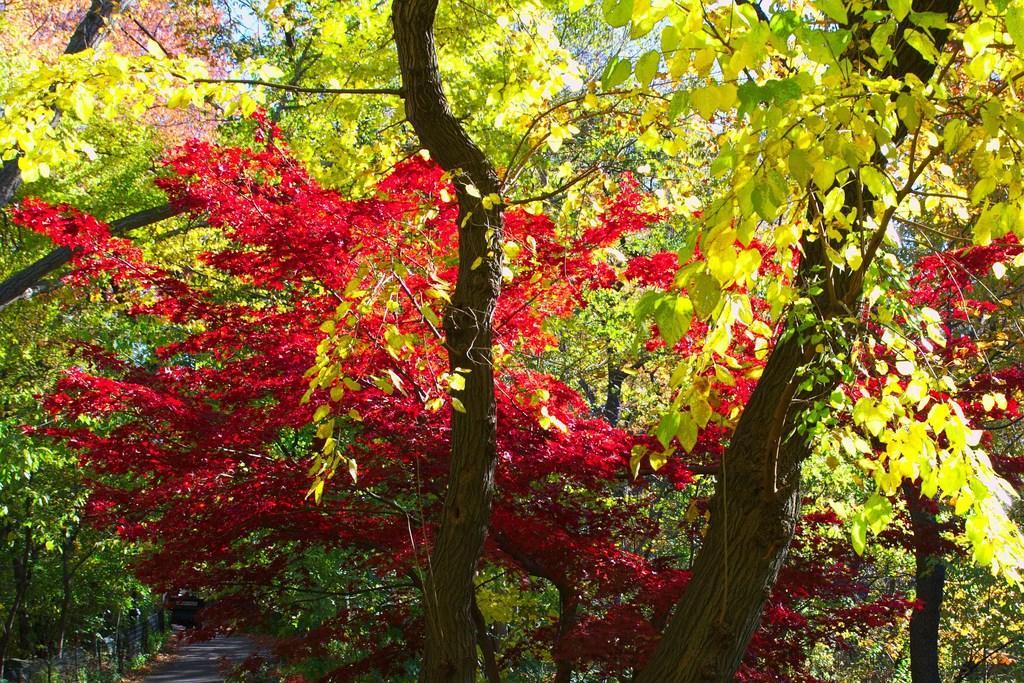Could you give a brief overview of what you see in this image? In this image we can see trees, path and fence. In the background we can see the sky. 